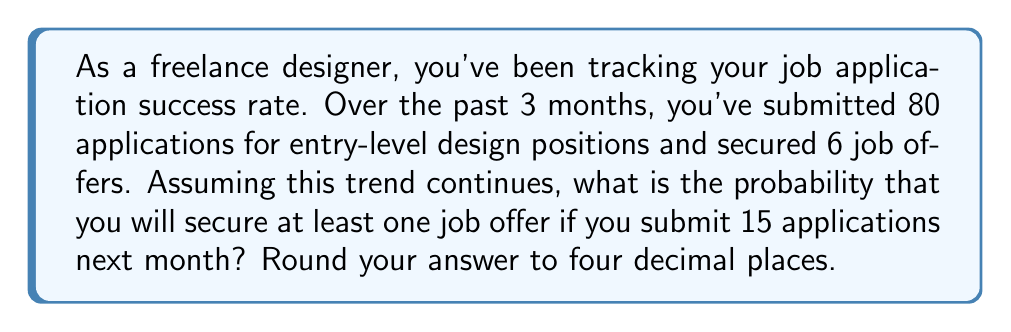Solve this math problem. To solve this problem, we'll use the binomial probability distribution and its complement.

1. Calculate the probability of success for a single application:
   $p = \frac{\text{number of successful applications}}{\text{total number of applications}} = \frac{6}{80} = 0.075$

2. The probability of not getting a job offer for a single application is:
   $q = 1 - p = 1 - 0.075 = 0.925$

3. We want to find the probability of getting at least one job offer in 15 applications. This is equivalent to 1 minus the probability of getting no job offers in 15 applications.

4. The probability of getting no job offers in 15 applications:
   $P(\text{no offers}) = q^{15} = 0.925^{15} = 0.3169$

5. Therefore, the probability of getting at least one job offer is:
   $P(\text{at least one offer}) = 1 - P(\text{no offers}) = 1 - 0.3169 = 0.6831$

6. Rounding to four decimal places:
   $0.6831 \approx 0.6831$
Answer: 0.6831 